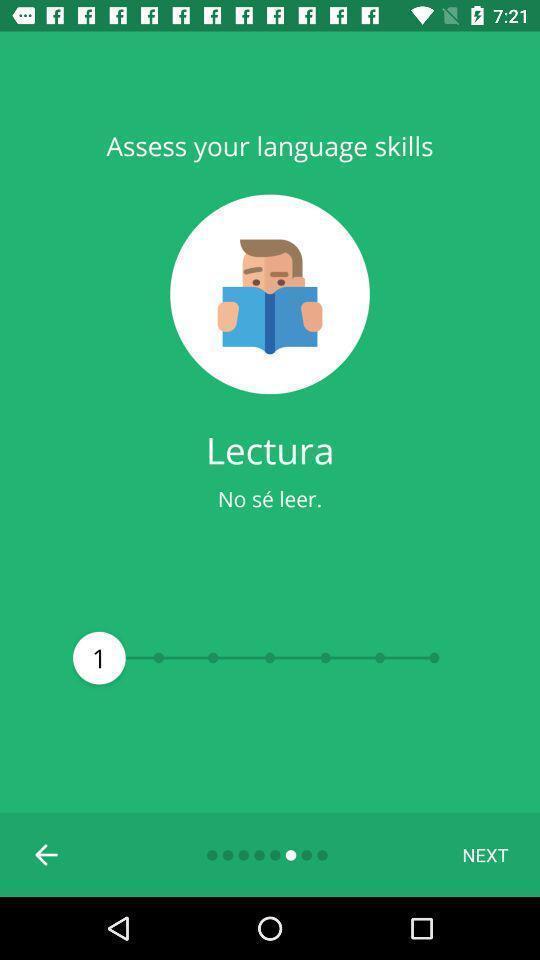Give me a narrative description of this picture. Screen showing the welcome page of language learning app. 